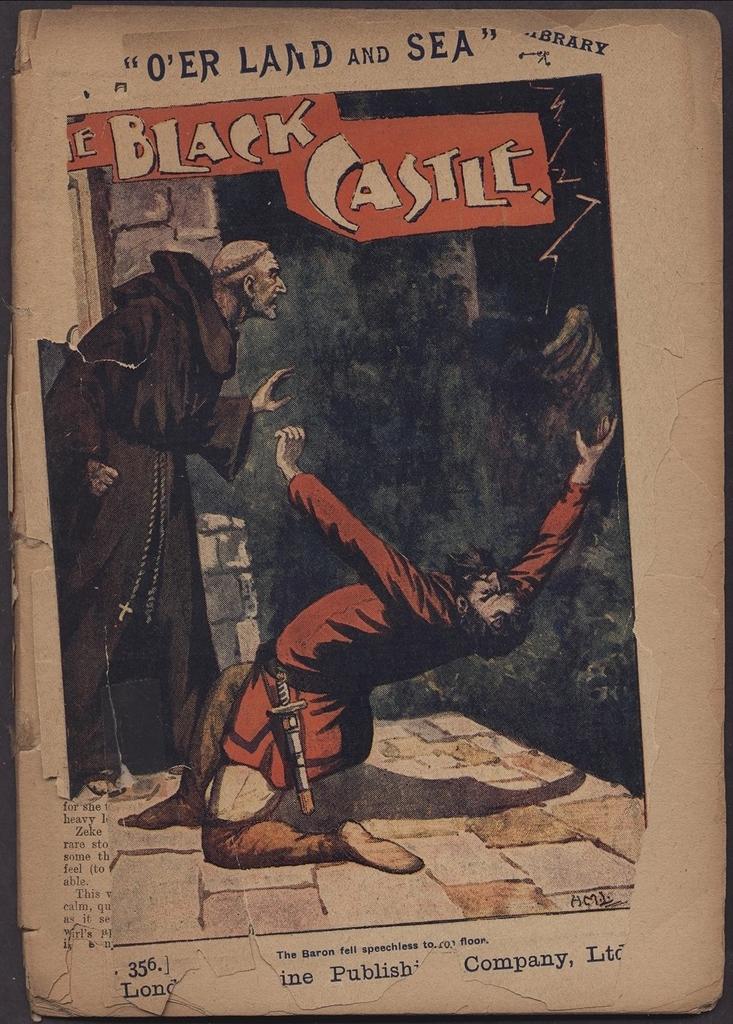What are the three numbers on the lower left corner?
Give a very brief answer. 356. 